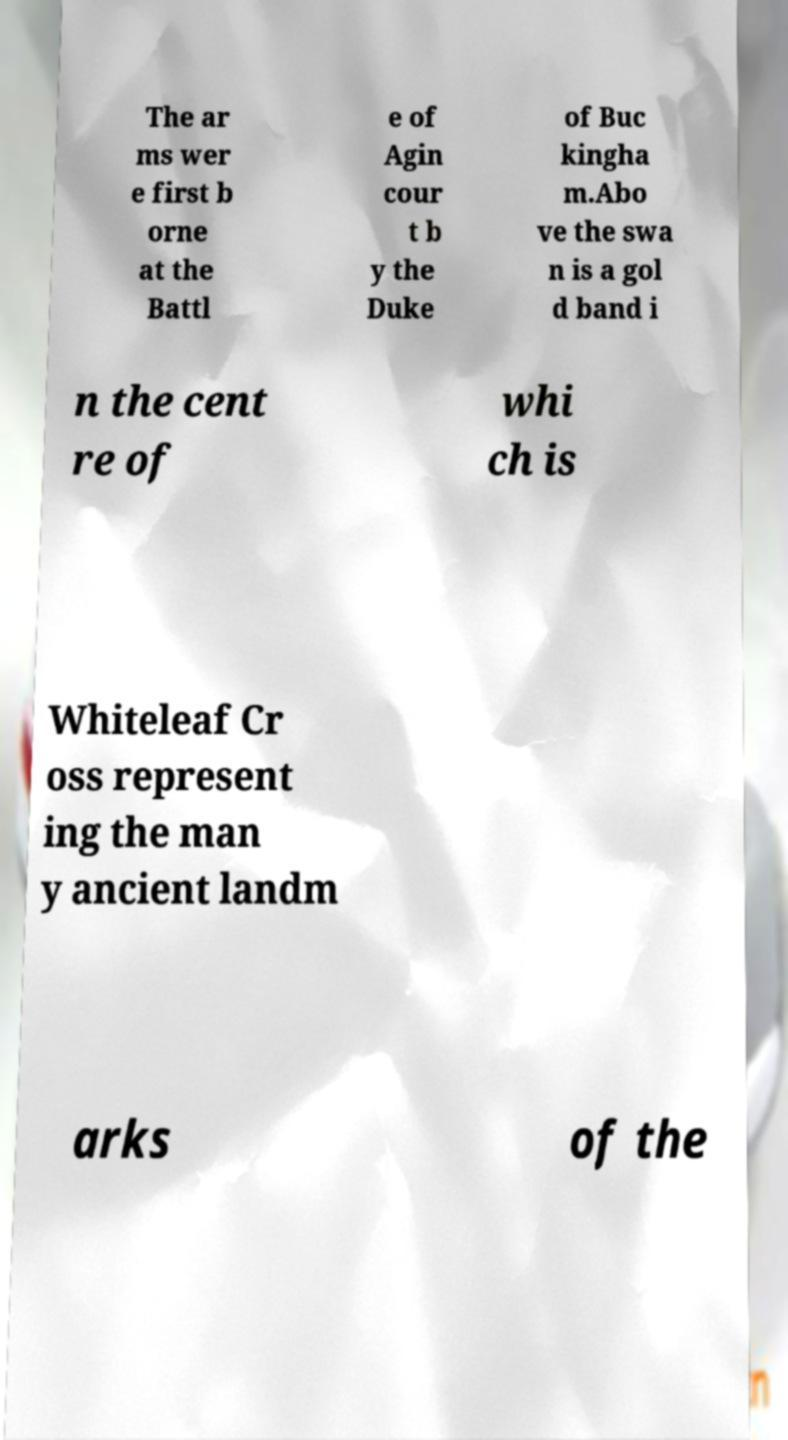Could you assist in decoding the text presented in this image and type it out clearly? The ar ms wer e first b orne at the Battl e of Agin cour t b y the Duke of Buc kingha m.Abo ve the swa n is a gol d band i n the cent re of whi ch is Whiteleaf Cr oss represent ing the man y ancient landm arks of the 